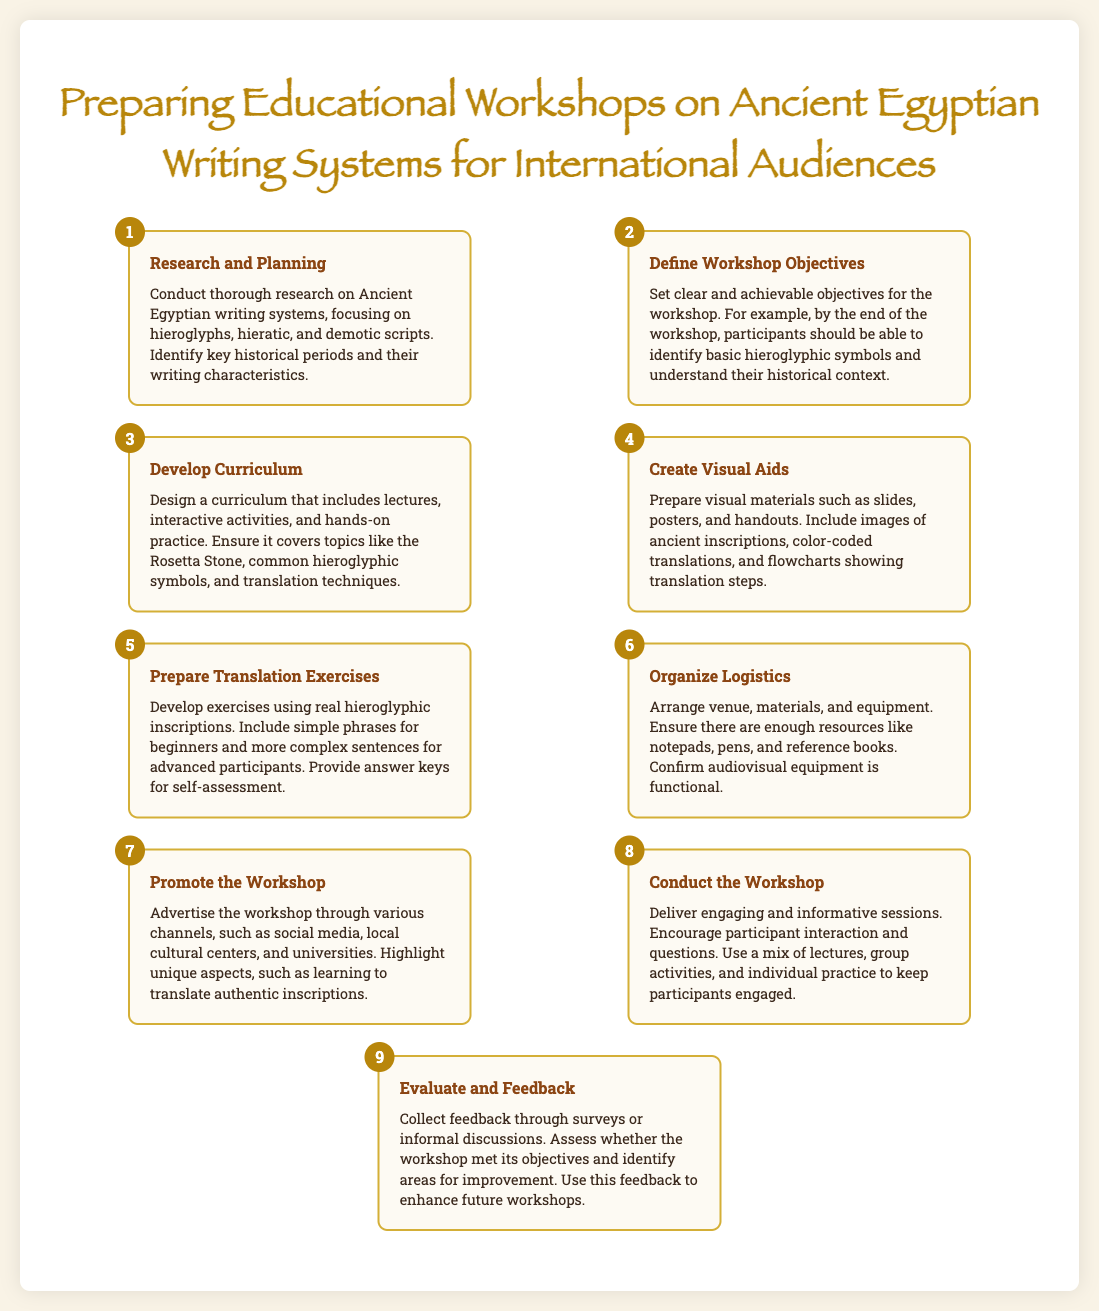What is the title of the workshop? The title is displayed prominently at the beginning of the document and states the focus of the workshop.
Answer: Preparing Educational Workshops on Ancient Egyptian Writing Systems for International Audiences What step involves creating visual materials? This information can be found in the section that describes one of the steps for preparing the workshop.
Answer: Create Visual Aids How many steps are listed in the preparation process? The number of steps can be counted from the individual sections outlined in the document.
Answer: 9 What is the objective of the workshop? The objectives are mentioned in the step that discusses defining them, focusing on what participants should learn.
Answer: Identify basic hieroglyphic symbols What should be included in the translation exercises? This detail provides specific content that will be part of the designed exercises, which are aimed at various levels.
Answer: Real hieroglyphic inscriptions In what step is logistics organized? This involves a specific stage in the preparation process, categorizing the tasks related to the logistics of the workshop.
Answer: Organize Logistics What should be emphasized to promote the workshop? The document suggests particular aspects that should be highlighted during the promotion phase based on its content.
Answer: Learning to translate authentic inscriptions What follows after conducting the workshop? This indicates the next phase in the process outlined in the infographic, focusing on assessment.
Answer: Evaluate and Feedback Which writing systems are focused on in the workshop? This ensures clarity on the main subjects of the workshop as described in the initial sections of the document.
Answer: Hieroglyphs, hieratic, and demotic scripts 